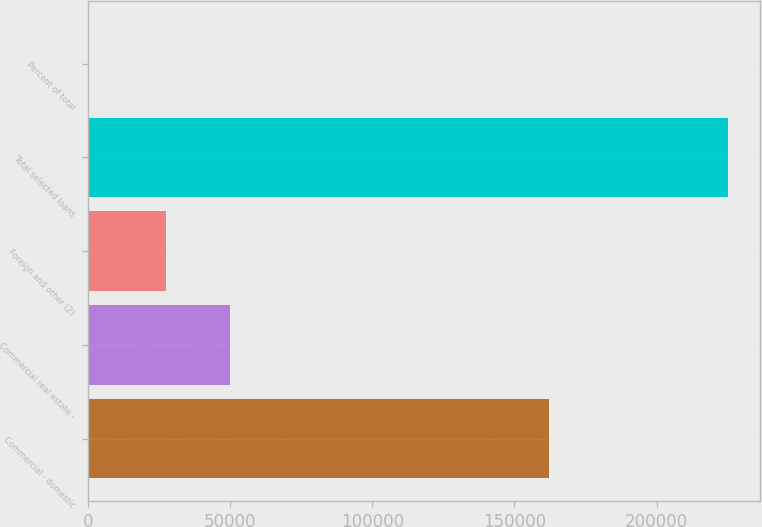<chart> <loc_0><loc_0><loc_500><loc_500><bar_chart><fcel>Commercial - domestic<fcel>Commercial real estate -<fcel>Foreign and other (2)<fcel>Total selected loans<fcel>Percent of total<nl><fcel>161982<fcel>49936.9<fcel>27437<fcel>225099<fcel>100<nl></chart> 